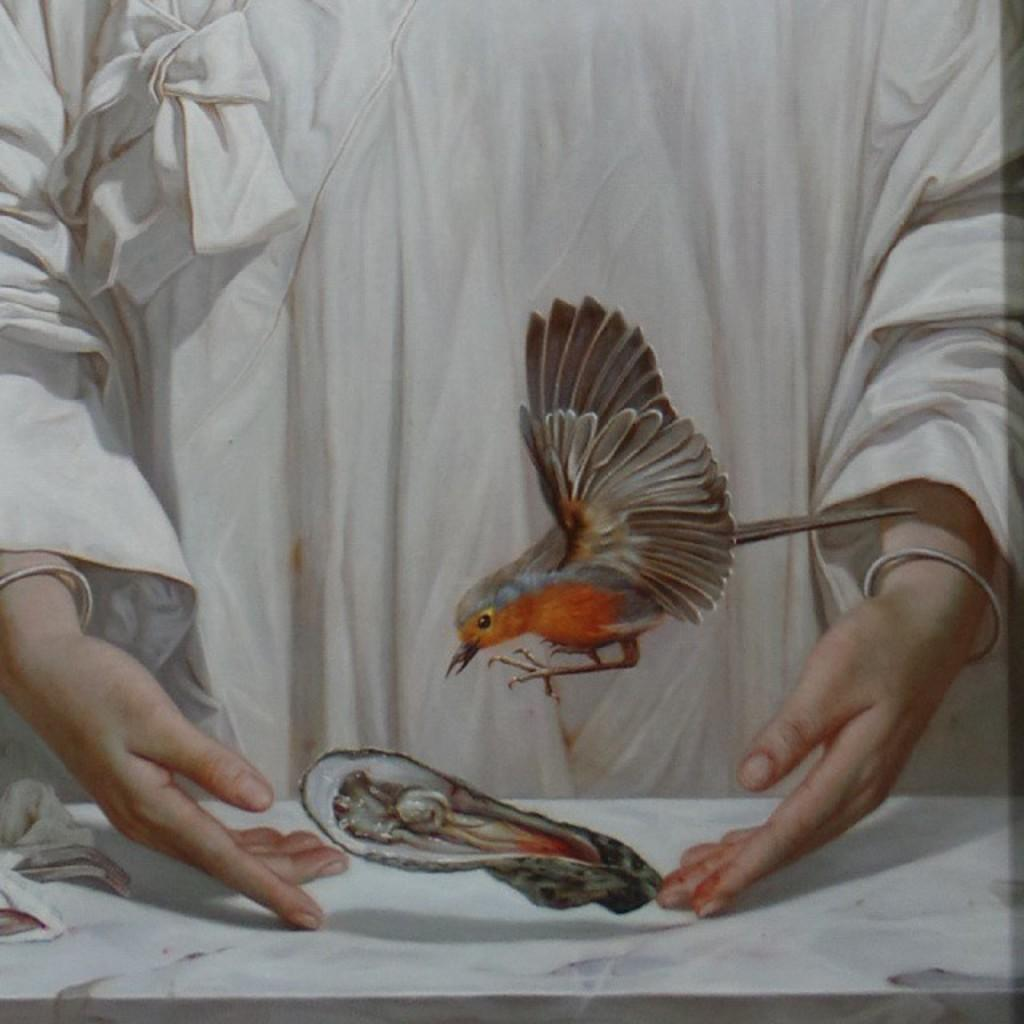What is the main subject of the image? There is a painting in the image. Can you describe the content of the painting? The painting features a person and a bird, along with other objects. What type of wheel can be seen in the painting? There is no wheel present in the painting; it features a person, a bird, and other objects. 